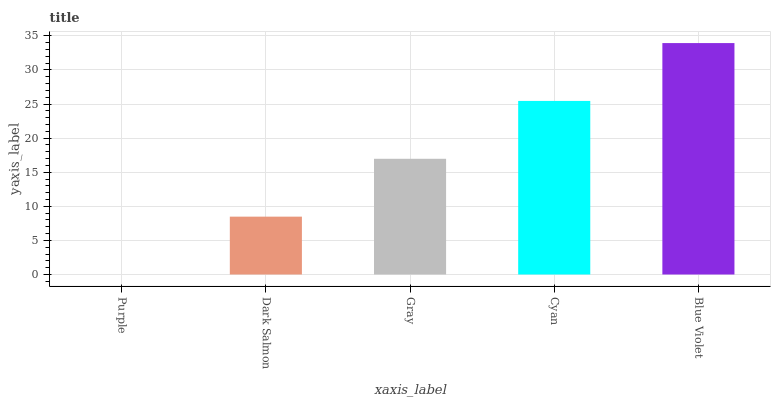Is Dark Salmon the minimum?
Answer yes or no. No. Is Dark Salmon the maximum?
Answer yes or no. No. Is Dark Salmon greater than Purple?
Answer yes or no. Yes. Is Purple less than Dark Salmon?
Answer yes or no. Yes. Is Purple greater than Dark Salmon?
Answer yes or no. No. Is Dark Salmon less than Purple?
Answer yes or no. No. Is Gray the high median?
Answer yes or no. Yes. Is Gray the low median?
Answer yes or no. Yes. Is Dark Salmon the high median?
Answer yes or no. No. Is Purple the low median?
Answer yes or no. No. 